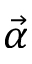<formula> <loc_0><loc_0><loc_500><loc_500>\vec { \alpha }</formula> 